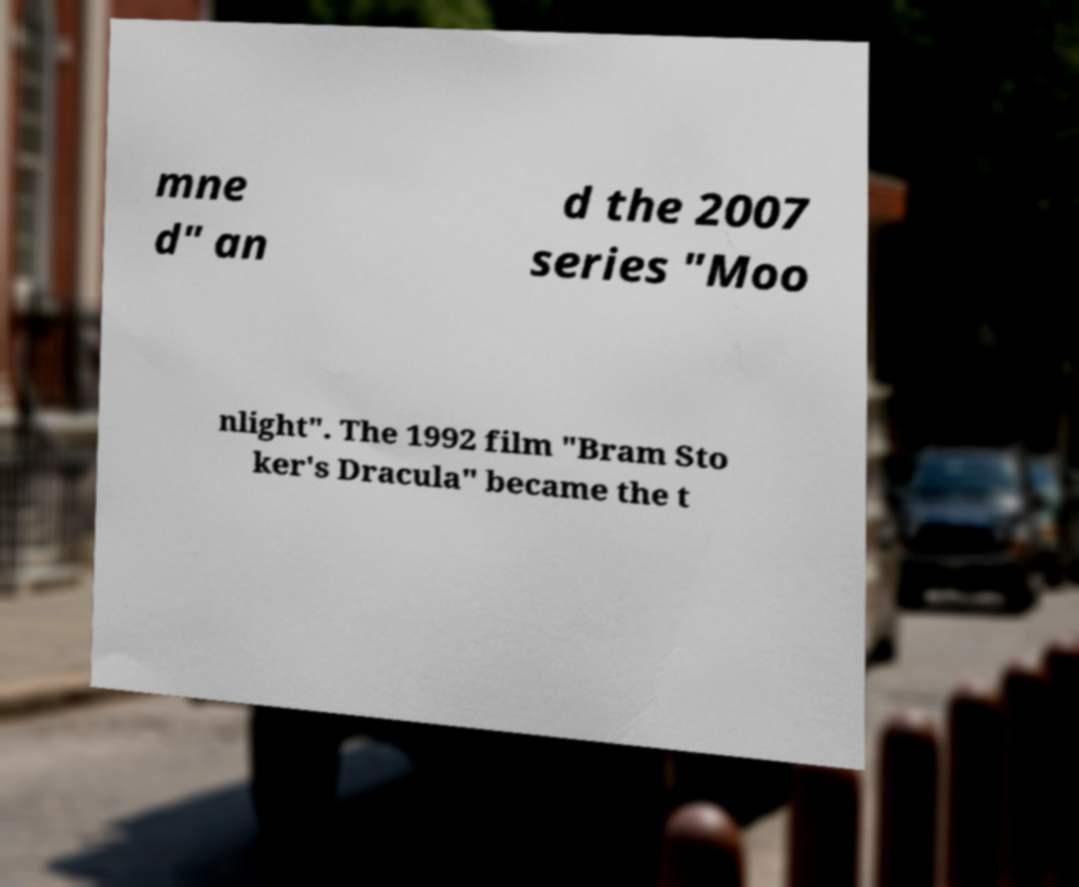Please read and relay the text visible in this image. What does it say? mne d" an d the 2007 series "Moo nlight". The 1992 film "Bram Sto ker's Dracula" became the t 